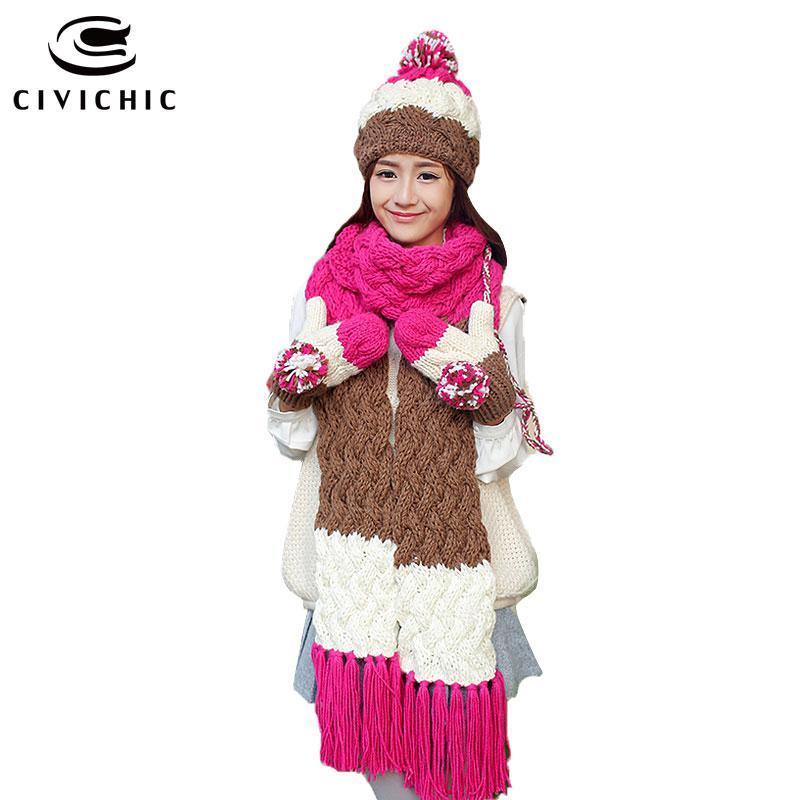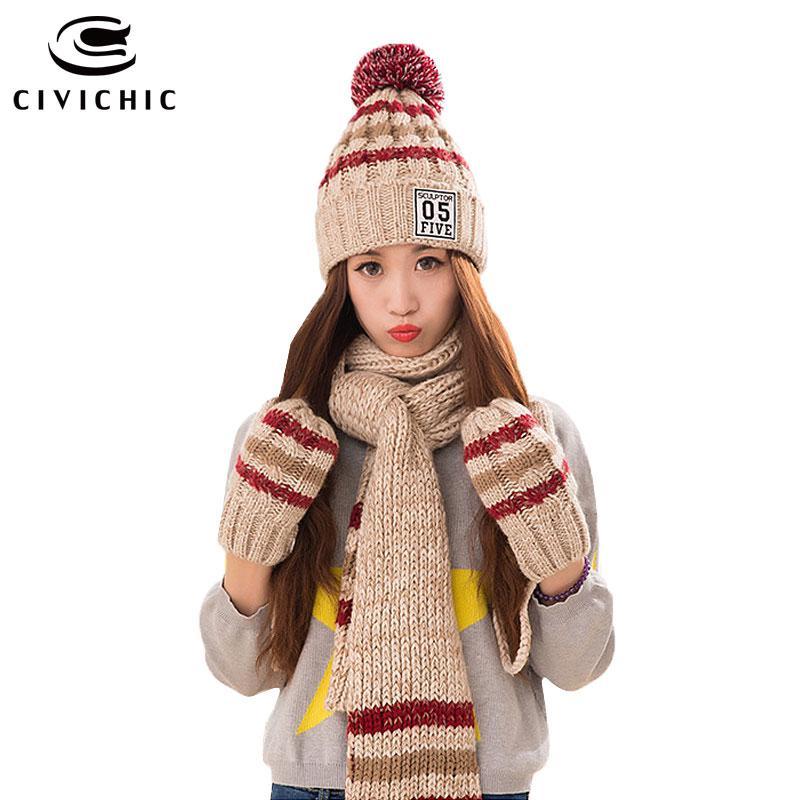The first image is the image on the left, the second image is the image on the right. Considering the images on both sides, is "there is a girl with a scarf covering the bottom half of her face" valid? Answer yes or no. No. The first image is the image on the left, the second image is the image on the right. Assess this claim about the two images: "A young girl is wearing a matching scarf, hat and gloves set that is white, brown and pink.". Correct or not? Answer yes or no. Yes. 